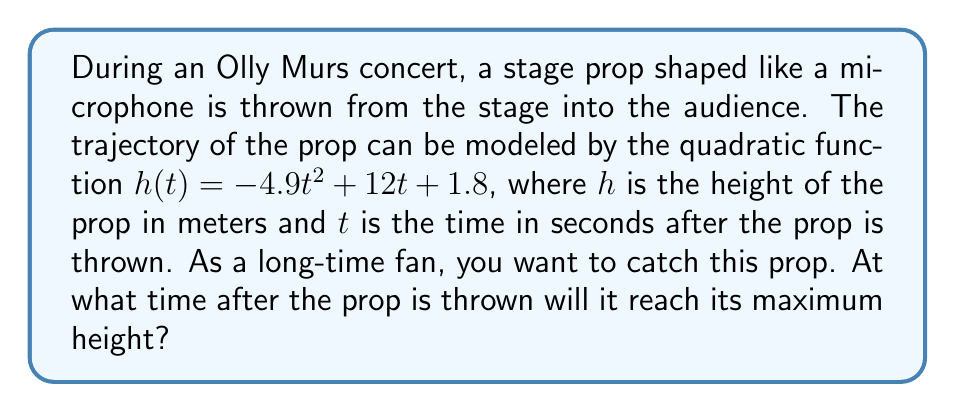Could you help me with this problem? To find the time when the prop reaches its maximum height, we need to follow these steps:

1) The quadratic function given is in the form $h(t) = -4.9t^2 + 12t + 1.8$, which can be written as $h(t) = a(t-h)^2 + k$, where $(h,k)$ is the vertex of the parabola.

2) For a quadratic function $f(x) = ax^2 + bx + c$, the x-coordinate of the vertex (which represents the time of maximum height in this case) is given by the formula:

   $t = -\frac{b}{2a}$

3) In our function, $a = -4.9$ and $b = 12$. Let's substitute these values:

   $t = -\frac{12}{2(-4.9)} = -\frac{12}{-9.8} = \frac{12}{9.8} \approx 1.22$

4) We can verify this by using the symmetric property of parabolas. The axis of symmetry passes through the vertex, and for this parabola, it's a vertical line at $t \approx 1.22$ seconds.

Therefore, the prop will reach its maximum height approximately 1.22 seconds after it's thrown.
Answer: $t \approx 1.22$ seconds 